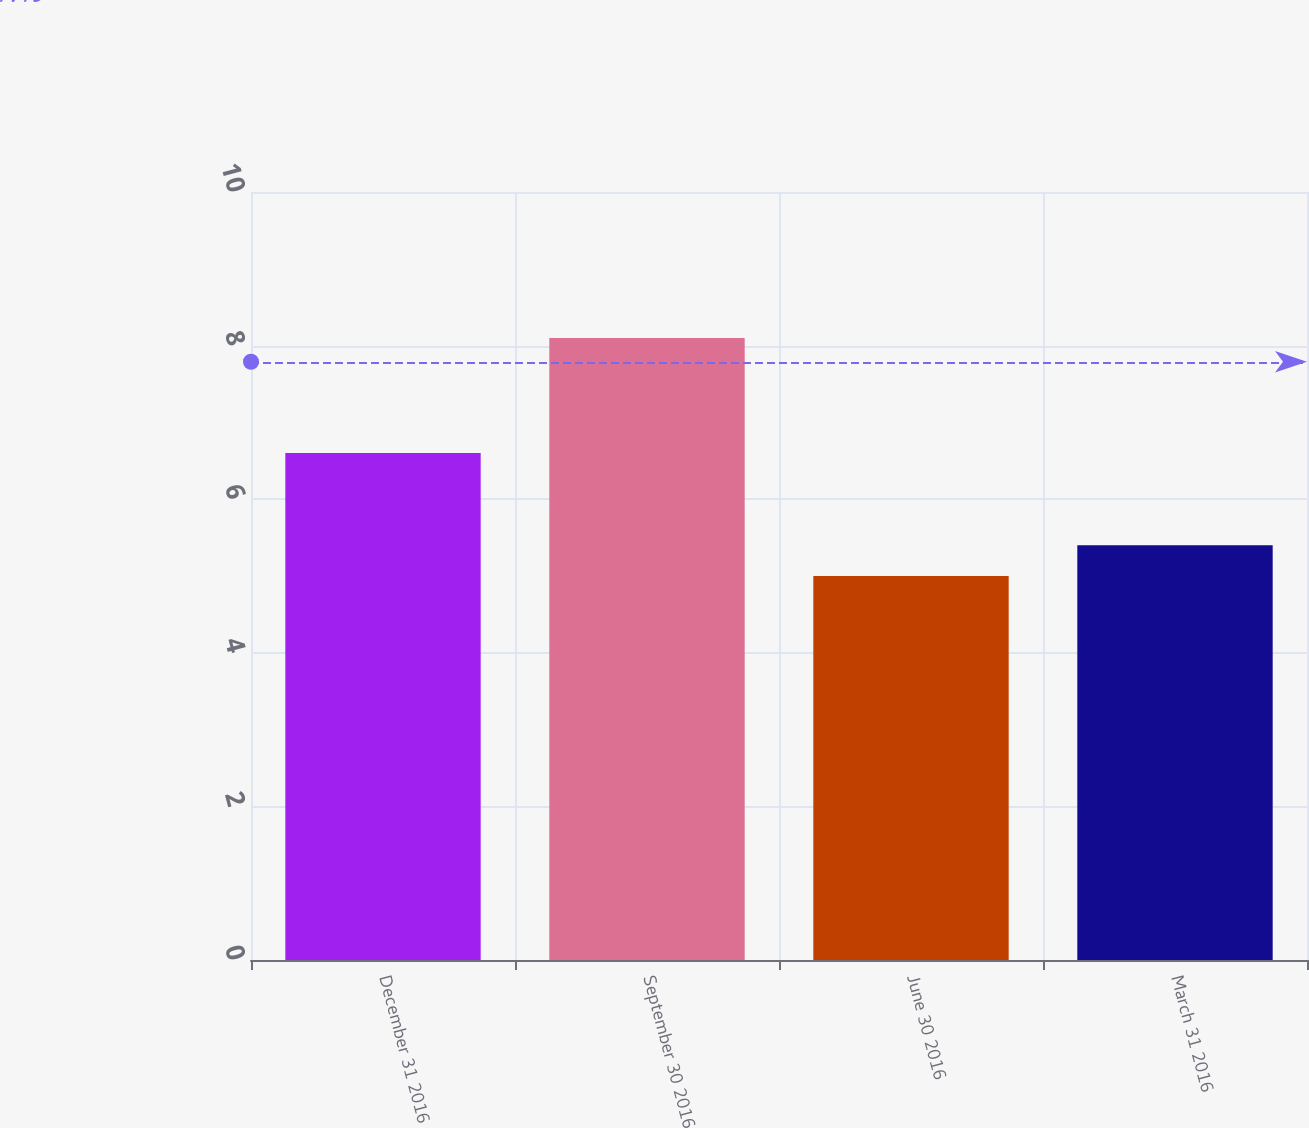<chart> <loc_0><loc_0><loc_500><loc_500><bar_chart><fcel>December 31 2016<fcel>September 30 2016<fcel>June 30 2016<fcel>March 31 2016<nl><fcel>6.6<fcel>8.1<fcel>5<fcel>5.4<nl></chart> 